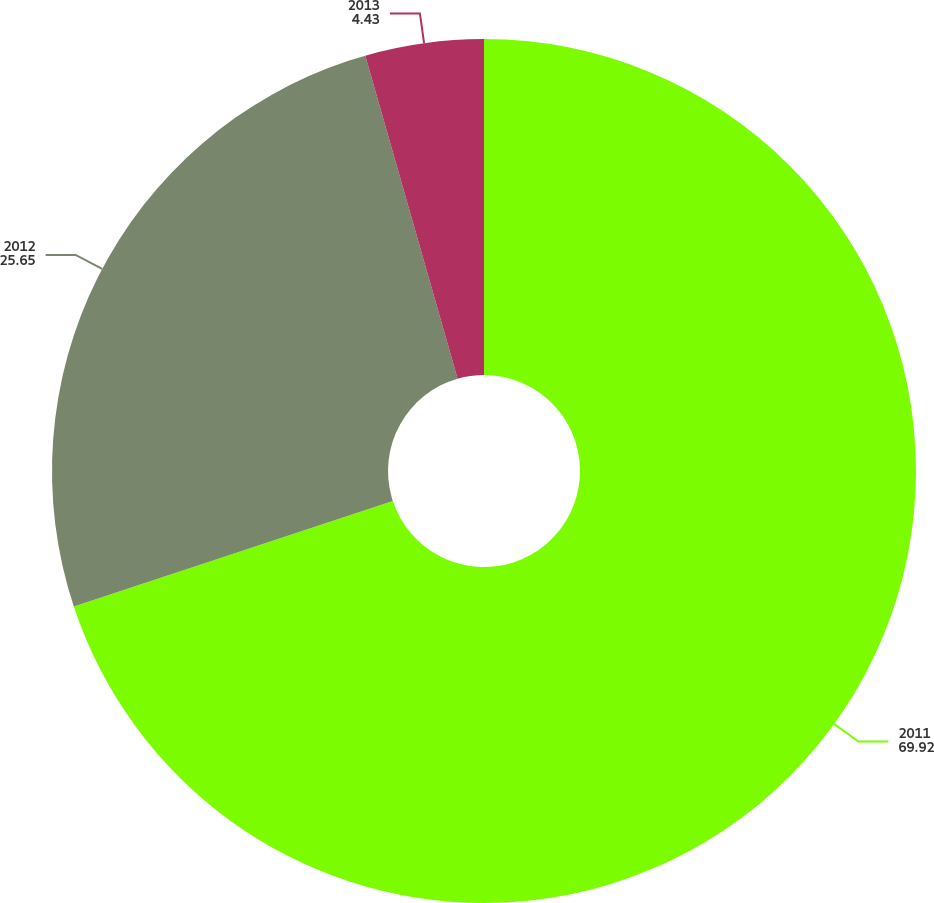Convert chart to OTSL. <chart><loc_0><loc_0><loc_500><loc_500><pie_chart><fcel>2011<fcel>2012<fcel>2013<nl><fcel>69.92%<fcel>25.65%<fcel>4.43%<nl></chart> 